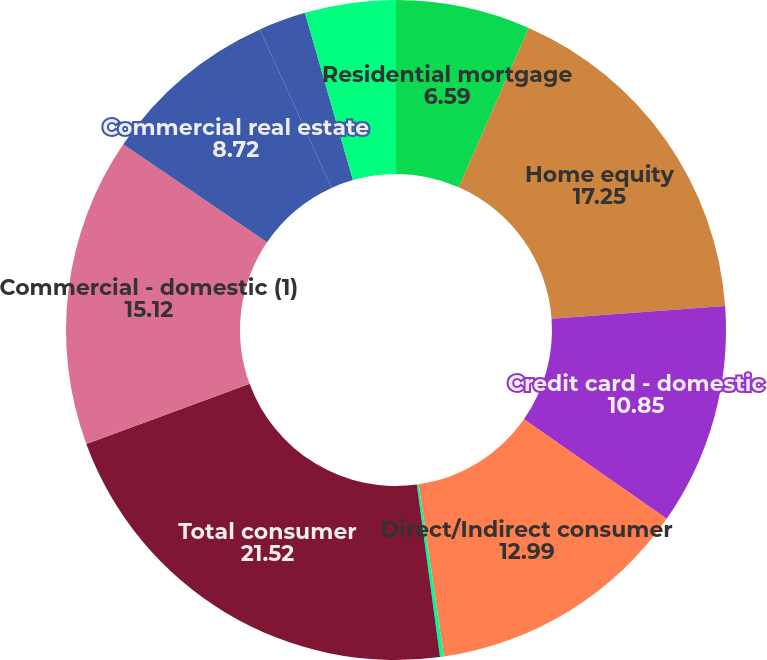Convert chart to OTSL. <chart><loc_0><loc_0><loc_500><loc_500><pie_chart><fcel>Residential mortgage<fcel>Home equity<fcel>Credit card - domestic<fcel>Direct/Indirect consumer<fcel>Other consumer<fcel>Total consumer<fcel>Commercial - domestic (1)<fcel>Commercial real estate<fcel>Commercial lease financing<fcel>Commercial - foreign<nl><fcel>6.59%<fcel>17.25%<fcel>10.85%<fcel>12.99%<fcel>0.19%<fcel>21.52%<fcel>15.12%<fcel>8.72%<fcel>2.32%<fcel>4.45%<nl></chart> 